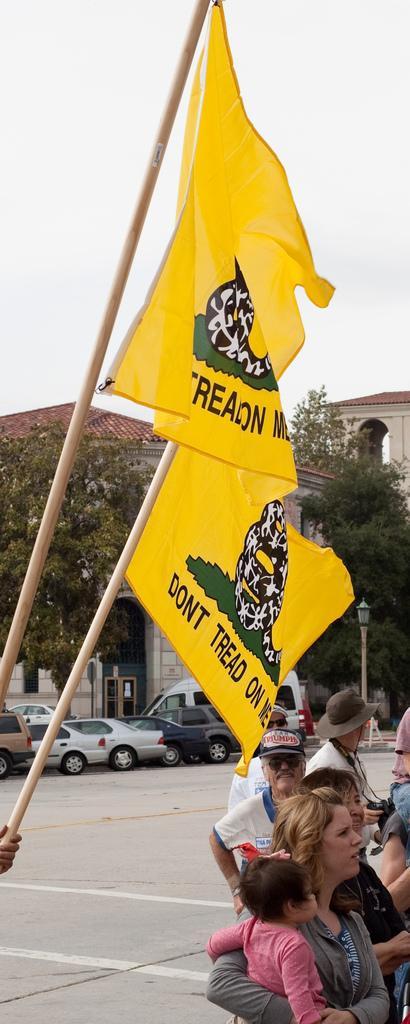Please provide a concise description of this image. In this image we can see some people standing on the road. We can also see two yellow color flags. In the background we can see buildings, trees and also some vehicles. Sky is also visible. 